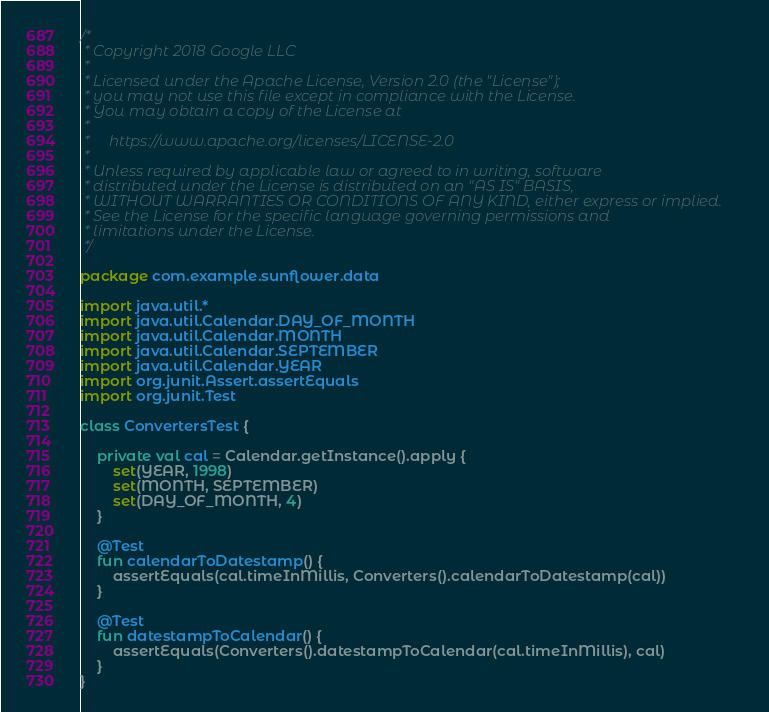<code> <loc_0><loc_0><loc_500><loc_500><_Kotlin_>/*
 * Copyright 2018 Google LLC
 *
 * Licensed under the Apache License, Version 2.0 (the "License");
 * you may not use this file except in compliance with the License.
 * You may obtain a copy of the License at
 *
 *     https://www.apache.org/licenses/LICENSE-2.0
 *
 * Unless required by applicable law or agreed to in writing, software
 * distributed under the License is distributed on an "AS IS" BASIS,
 * WITHOUT WARRANTIES OR CONDITIONS OF ANY KIND, either express or implied.
 * See the License for the specific language governing permissions and
 * limitations under the License.
 */

package com.example.sunflower.data

import java.util.*
import java.util.Calendar.DAY_OF_MONTH
import java.util.Calendar.MONTH
import java.util.Calendar.SEPTEMBER
import java.util.Calendar.YEAR
import org.junit.Assert.assertEquals
import org.junit.Test

class ConvertersTest {

    private val cal = Calendar.getInstance().apply {
        set(YEAR, 1998)
        set(MONTH, SEPTEMBER)
        set(DAY_OF_MONTH, 4)
    }

    @Test
    fun calendarToDatestamp() {
        assertEquals(cal.timeInMillis, Converters().calendarToDatestamp(cal))
    }

    @Test
    fun datestampToCalendar() {
        assertEquals(Converters().datestampToCalendar(cal.timeInMillis), cal)
    }
}
</code> 